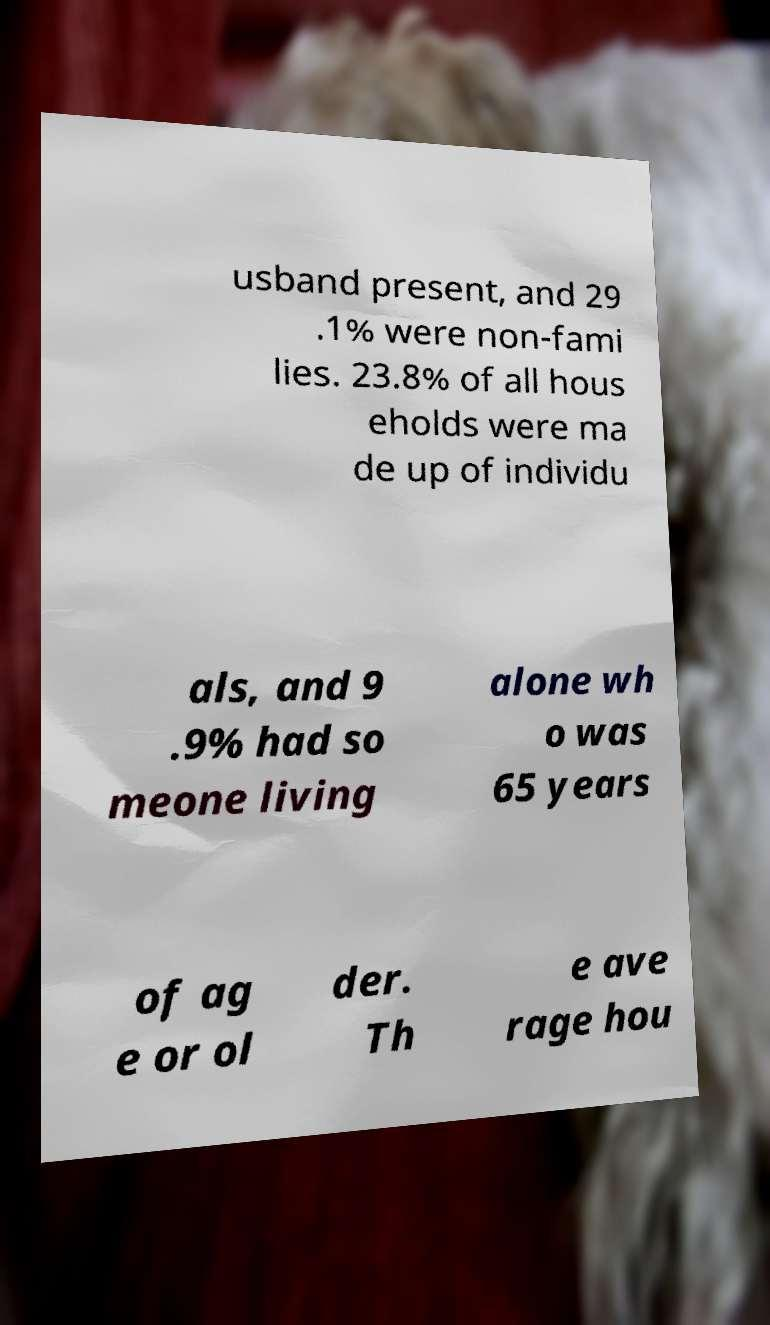Could you extract and type out the text from this image? usband present, and 29 .1% were non-fami lies. 23.8% of all hous eholds were ma de up of individu als, and 9 .9% had so meone living alone wh o was 65 years of ag e or ol der. Th e ave rage hou 